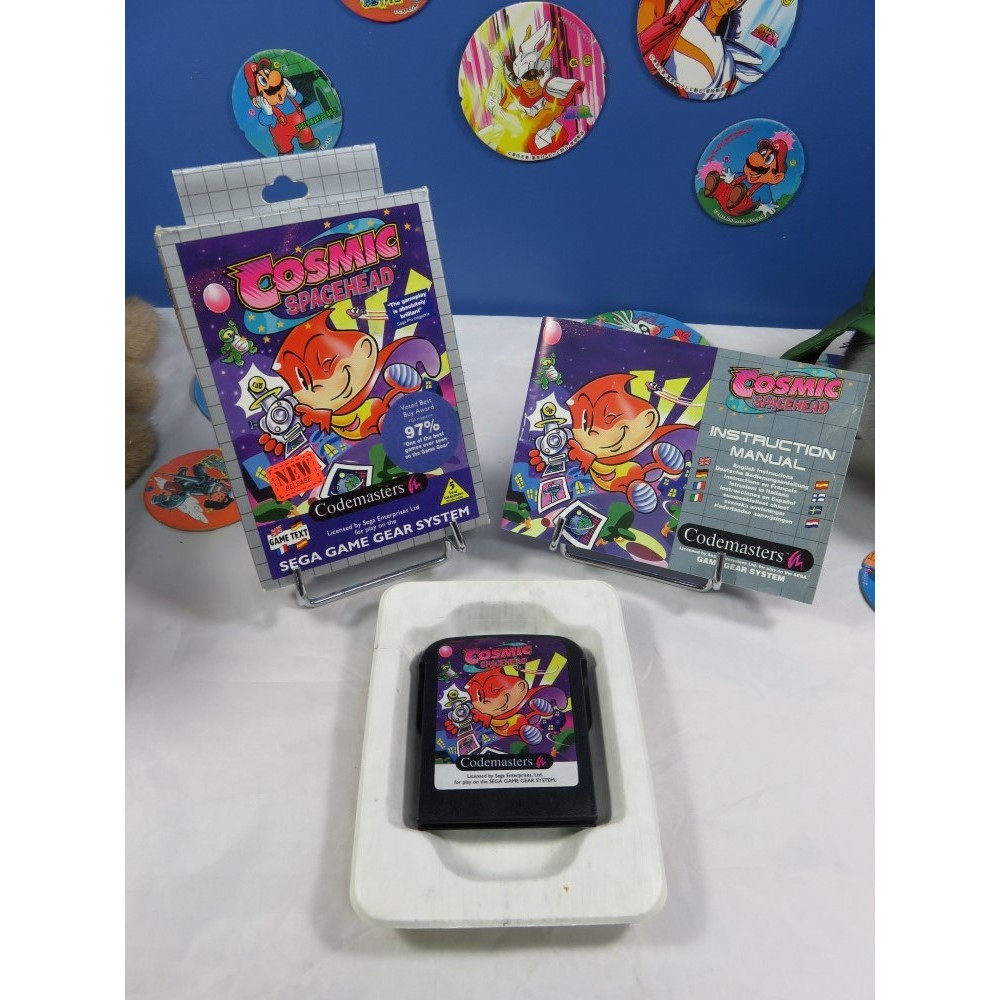What is the first thing that catches your eye in the promotional materials for the game Cosmic Spacehead? The first thing that catches my eye in the promotional materials for 'Cosmic Spacehead' is the vibrant and colorful character artwork on the game’s packaging. The main character's cheerful and lively design immediately draws attention, making it a focal point of the display. How do the background elements contribute to the overall marketing strategy? The background elements, such as the various badges and stickers featuring different characters, significantly contribute to the overall marketing strategy by creating a sense of a larger, engaging universe. These elements not only enhance visual appeal but also appeal to collectors and fans by providing additional merchandise that extends the experience beyond the game itself. This tactic helps in building a stronger, more immersive brand presence. Imagine there's a special feature about the main character, Cosmic Spacehead. What would it be? A special feature about the main character, Cosmic Spacehead, could be his ability to communicate and interact with various alien species using a universal translator gadget. This gadget not only allows him to understand and speak different alien languages but also provides him with unique insights and strategies that help him navigate and solve puzzles throughout his cosmic adventures. This feature emphasizes his cleverness and resourcefulness, making him a more engaging and relatable hero for players. 